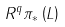<formula> <loc_0><loc_0><loc_500><loc_500>R ^ { q } \pi _ { * } \left ( L \right )</formula> 